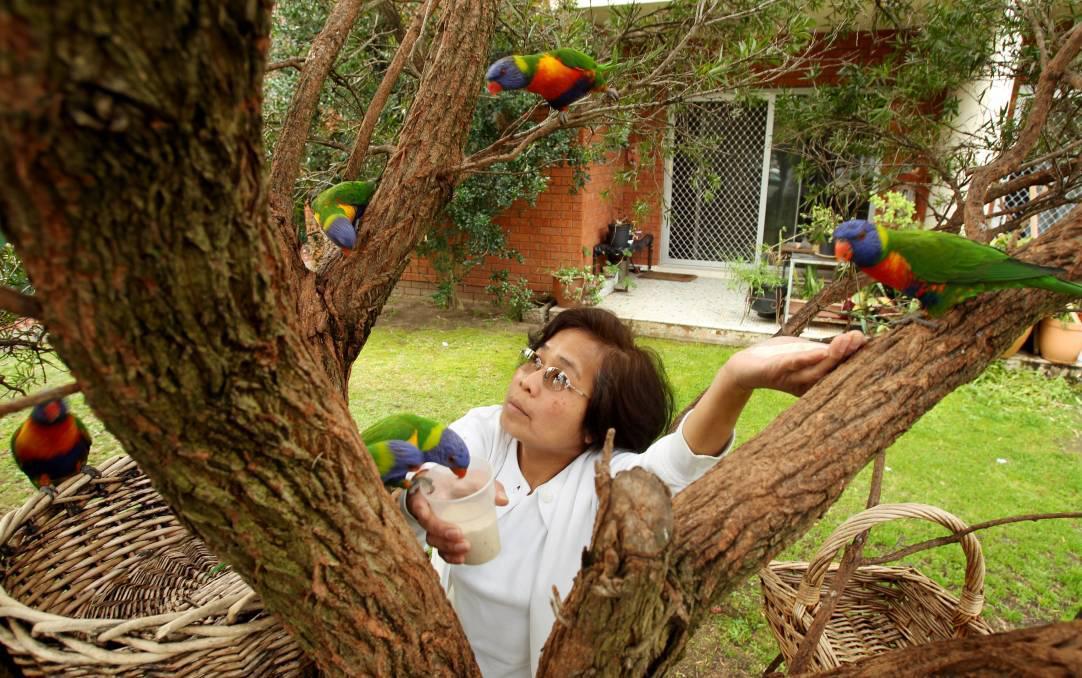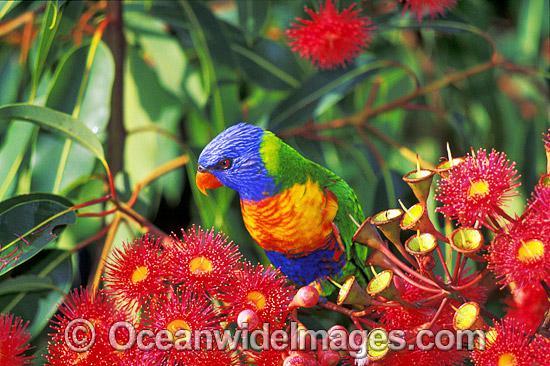The first image is the image on the left, the second image is the image on the right. For the images displayed, is the sentence "In one of the images there is a bird in a tree with red flowers." factually correct? Answer yes or no. Yes. The first image is the image on the left, the second image is the image on the right. Assess this claim about the two images: "An image shows a parrot perched among branches of red flowers with tendril petals.". Correct or not? Answer yes or no. Yes. 